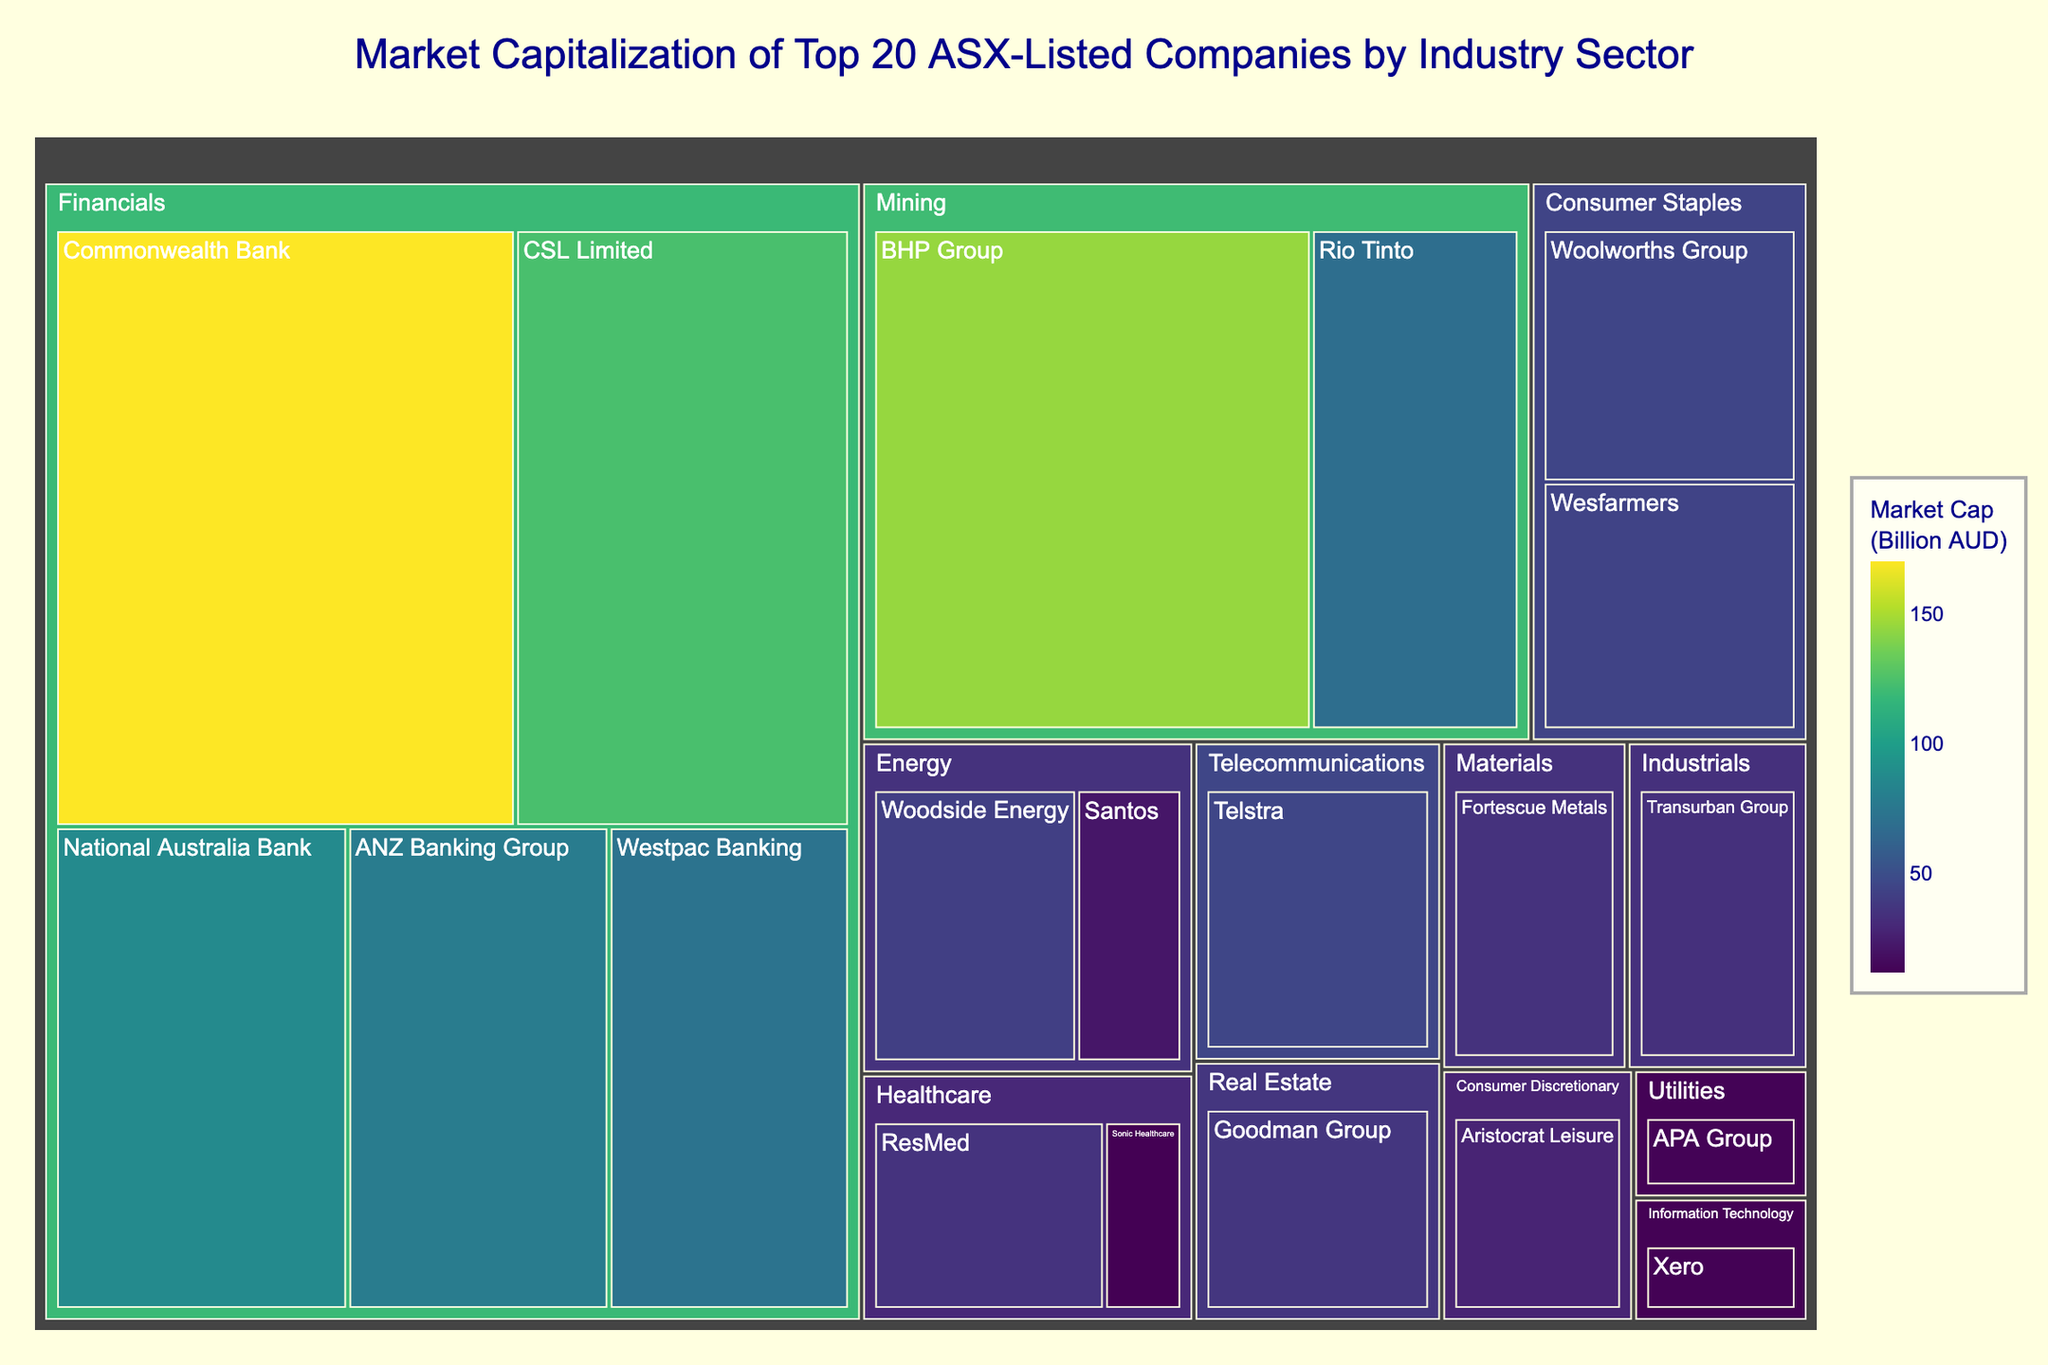What's the title of the treemap? The title is prominently displayed at the top center of the treemap.
Answer: Market Capitalization of Top 20 ASX-Listed Companies by Industry Sector Which company has the largest market capitalization? By observing the largest section in the treemap, the company Commonwealth Bank has the largest market capitalization.
Answer: Commonwealth Bank What is the combined market capitalization of the companies in the Financials industry? The Financials industry contains the companies Commonwealth Bank (170.5), CSL Limited (123.8), National Australia Bank (87.6), ANZ Banking Group (78.3), and Westpac Banking (72.1). Summing these values gives 532.3 billion AUD.
Answer: 532.3 billion AUD Which industry has the smallest combined market capitalization? By comparing the total area occupied by each industry, the smallest area is the industry with the least combined market cap, which is Information Technology.
Answer: Information Technology What is the market capitalization of the company ResMed? Find the section for ResMed in the Healthcare industry and note the market cap listed, which is 35.2 billion AUD.
Answer: 35.2 billion AUD How does the market cap of BHP Group compare with Rio Tinto? Locate both BHP Group and Rio Tinto in the Mining industry. BHP Group has a market cap of 145.2 billion AUD, while Rio Tinto has 68.9 billion AUD. Therefore, BHP Group's market cap is larger.
Answer: BHP Group is larger Which industry has the highest number of companies listed? Count the number of companies in each industry. The Financials industry has the highest count with five companies.
Answer: Financials What is the difference in market capitalization between Woodside Energy and Santos? Woodside Energy has a market cap of 41.5 billion AUD and Santos has 21.5 billion AUD. Subtract Santos's market cap from Woodside Energy's to get the difference, 41.5 - 21.5 = 20 billion AUD.
Answer: 20 billion AUD What percentage of the total market capitalization does the Energy sector represent? Calculate the combined market cap of the Energy sector (Woodside Energy 41.5 + Santos 21.5 = 63 billion AUD). Sum up the market caps of all companies in the treemap (955.4 billion AUD). The percentage is (63 / 955.4) * 100 ≈ 6.60%.
Answer: 6.60% Which companies are listed under the Consumer Staples industry? Look for the companies in the Consumer Staples section: Woolworths Group and Wesfarmers.
Answer: Woolworths Group, Wesfarmers 